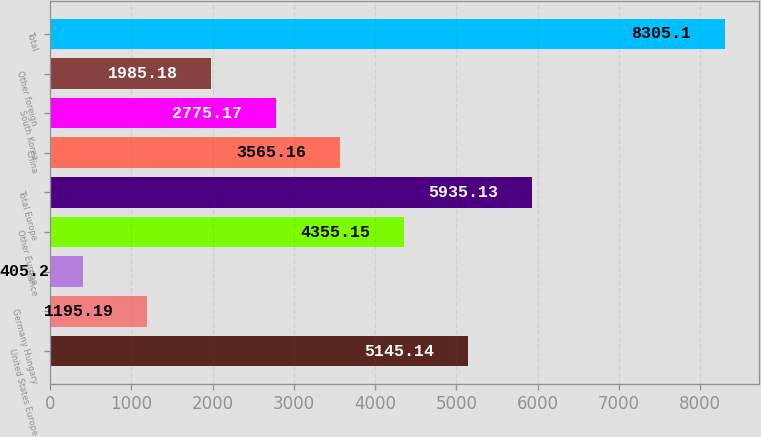Convert chart to OTSL. <chart><loc_0><loc_0><loc_500><loc_500><bar_chart><fcel>United States Europe<fcel>Germany Hungary<fcel>France<fcel>Other Europe<fcel>Total Europe<fcel>China<fcel>South Korea<fcel>Other foreign<fcel>Total<nl><fcel>5145.14<fcel>1195.19<fcel>405.2<fcel>4355.15<fcel>5935.13<fcel>3565.16<fcel>2775.17<fcel>1985.18<fcel>8305.1<nl></chart> 